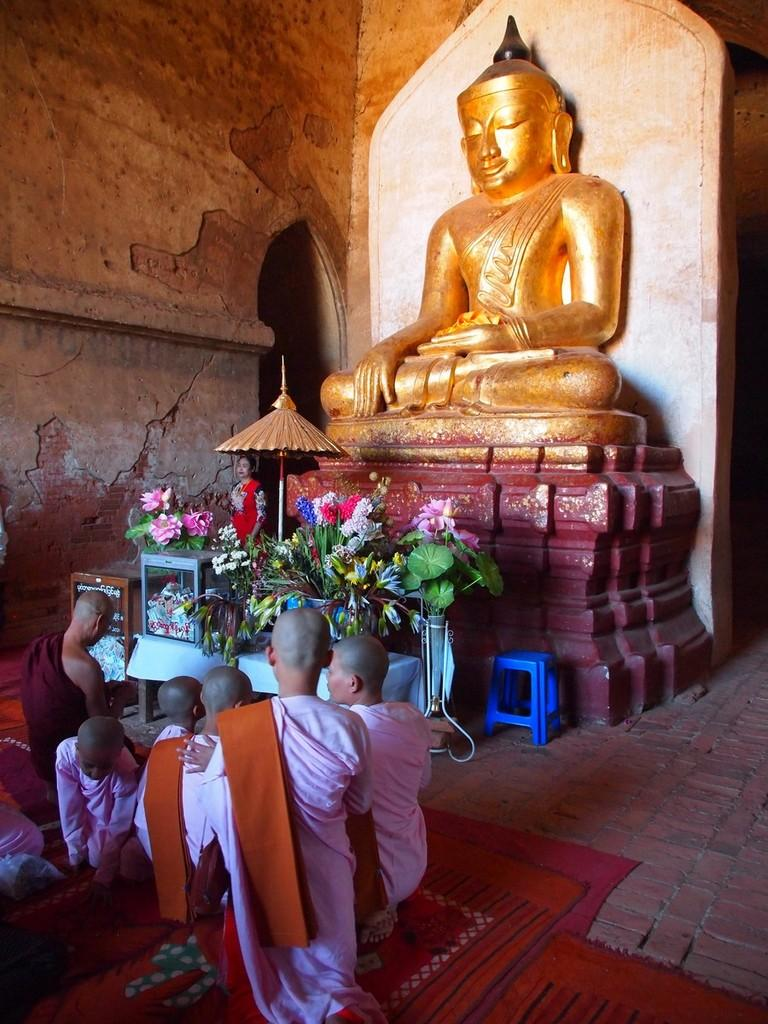What type of surface can be seen in the image? There is ground visible in the image. What objects are on the ground in the image? There are floor mats in the image. Who or what is present in the image? There are persons in the image. What type of plants are in the image? There are flowers in the image. What type of seating is present in the image? There is a blue-colored stool in the image. What type of decorative object is in the image? There is a gold-colored statue in the image. What color is the wall in the background of the image? There is a brown-colored wall in the background of the image. Can you tell me how many chess pieces are on the blue-colored stool in the image? There are no chess pieces present in the image; only a blue-colored stool and a gold-colored statue are visible. What type of branch is being used as a walking stick by the person in the image? There is no walking stick or branch present in the image. 